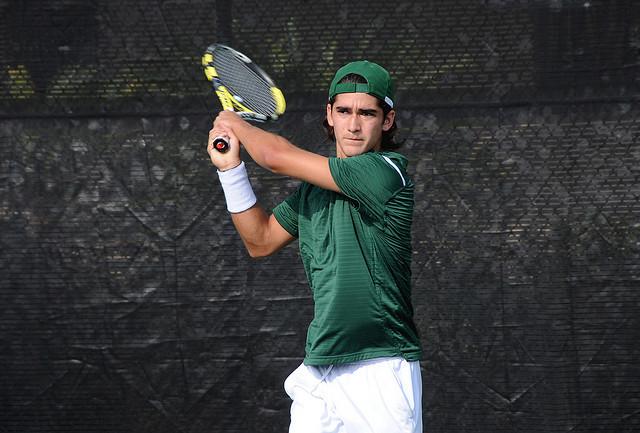Does his shirt match his hat?
Quick response, please. Yes. What color is his hat?
Answer briefly. Green. Does the person have a hat on?
Give a very brief answer. Yes. 